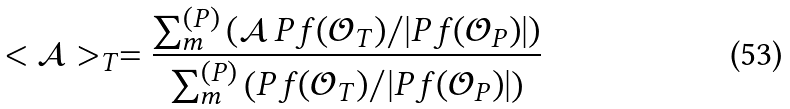<formula> <loc_0><loc_0><loc_500><loc_500>< \mathcal { A } > _ { T } = \frac { \sum _ { m } ^ { ( P ) } \left ( \mathcal { A } \, P f ( \mathcal { O } _ { T } ) / | P f ( \mathcal { O } _ { P } ) | \right ) } { \sum _ { m } ^ { ( P ) } \left ( P f ( \mathcal { O } _ { T } ) / | P f ( \mathcal { O } _ { P } ) | \right ) }</formula> 